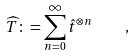Convert formula to latex. <formula><loc_0><loc_0><loc_500><loc_500>\widehat { T } \colon = \sum _ { n = 0 } ^ { \infty } \hat { t } ^ { \otimes n } \quad ,</formula> 